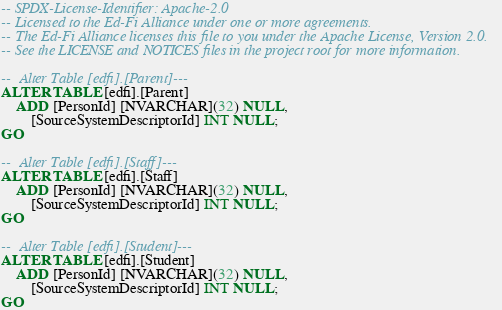Convert code to text. <code><loc_0><loc_0><loc_500><loc_500><_SQL_>-- SPDX-License-Identifier: Apache-2.0
-- Licensed to the Ed-Fi Alliance under one or more agreements.
-- The Ed-Fi Alliance licenses this file to you under the Apache License, Version 2.0.
-- See the LICENSE and NOTICES files in the project root for more information.

--  Alter Table [edfi].[Parent]---
ALTER TABLE [edfi].[Parent]
    ADD [PersonId] [NVARCHAR](32) NULL,
        [SourceSystemDescriptorId] INT NULL;
GO

--  Alter Table [edfi].[Staff]---
ALTER TABLE [edfi].[Staff]
    ADD [PersonId] [NVARCHAR](32) NULL,
        [SourceSystemDescriptorId] INT NULL;
GO

--  Alter Table [edfi].[Student]---
ALTER TABLE [edfi].[Student]
    ADD [PersonId] [NVARCHAR](32) NULL,
        [SourceSystemDescriptorId] INT NULL;
GO</code> 